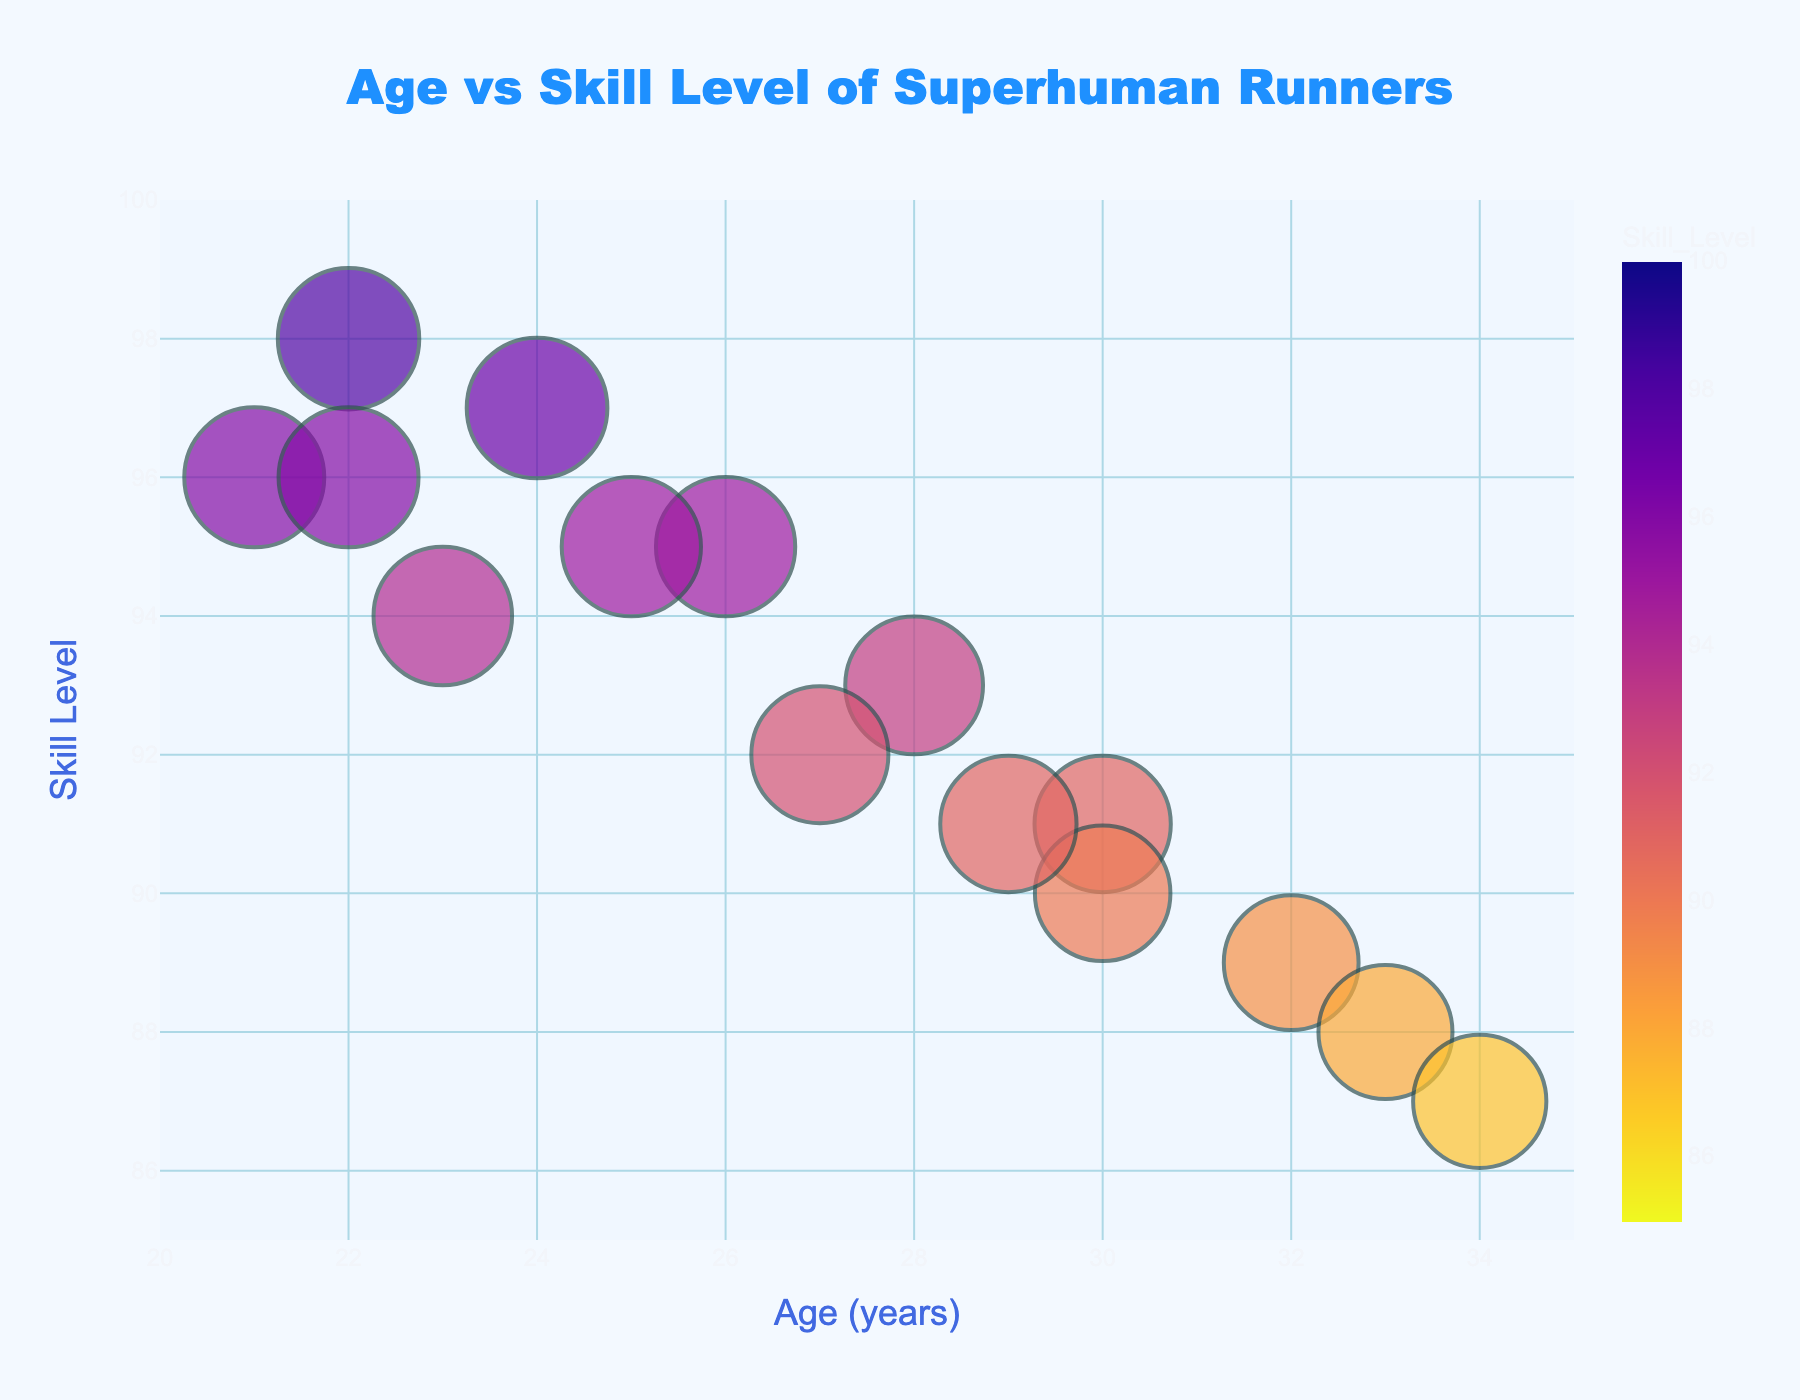What is the title of the plot? The title is prominently displayed at the top center of the plot. It reads "Age vs Skill Level of Superhuman Runners".
Answer: Age vs Skill Level of Superhuman Runners What is the range of ages displayed in the plot? The x-axis represents the age and is labeled for values between 20 and 35 years.
Answer: 20 to 35 years Which runner has the highest skill level and what is that level? The bubble with the highest y-coordinate represents the highest skill level. Usain Bolt is at the top with a skill level of 98.
Answer: Usain Bolt, 98 How does the skill level of Michael Norman compare to Noah Lyles? Compare the y-coordinates of the bubbles labeled with their names. Michael Norman has a skill level of 96, while Noah Lyles has a skill level of 94.
Answer: Michael Norman has a higher skill level by 2 points What is the average skill level of runners aged 30? Identify the bubbles representing runners aged 30 and then calculate the average of their skill levels. Andre De Grasse (91) and Nesta Carter (90) are aged 30. The average is (91 + 90) / 2.
Answer: 90.5 Are there more runners aged below 25 or above 30? Count the number of bubbles for ages below 25 and above 30. There are 5 runners below 25 and 4 runners above 30.
Answer: More runners aged below 25 Which runner is closest in age and skill level to Justin Gatlin? Justin Gatlin is aged 28 with a skill level of 93. Check nearby bubbles, Tyson Gay aged 27 with skill level 92 is closest.
Answer: Tyson Gay What is the color trend observed in the bubbles as skill levels increase? The bubbles are colored using a continuous scale. Higher skill levels have a color closer to the start of the color scale (lighter) while lower skill levels get closer to the end of the scale (darker).
Answer: Bubbles get lighter What is the range of skill levels depicted in the chart? The y-axis shows the range of skill levels, from 85 to 100.
Answer: 85 to 100 How many runners have a skill level above 95? Count the bubbles with y-coordinates above 95, which corresponds to skill levels above 95. There are 5 such runners.
Answer: 5 runners 